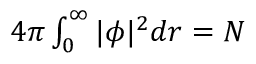Convert formula to latex. <formula><loc_0><loc_0><loc_500><loc_500>\begin{array} { r } { 4 \pi \int _ { 0 } ^ { \infty } | \phi | ^ { 2 } d r = N } \end{array}</formula> 